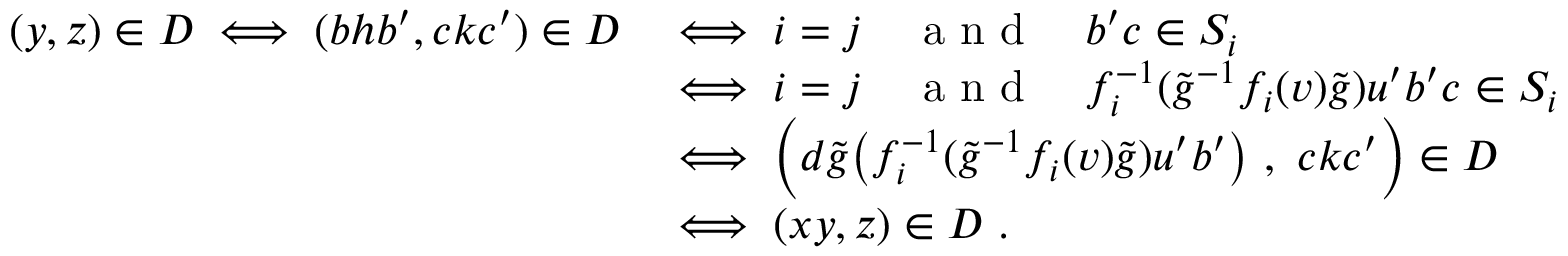<formula> <loc_0><loc_0><loc_500><loc_500>\begin{array} { r l } { ( y , z ) \in D \iff ( b h b ^ { \prime } , c k c ^ { \prime } ) \in D } & { \iff i = j \quad a n d \quad b ^ { \prime } c \in S _ { i } } \\ & { \iff i = j \quad a n d \quad f _ { i } ^ { - 1 } ( \widetilde { g } ^ { - 1 } f _ { i } ( v ) \widetilde { g } ) u ^ { \prime } b ^ { \prime } c \in S _ { i } } \\ & { \iff \left ( d \widetilde { g } \left ( f _ { i } ^ { - 1 } ( \widetilde { g } ^ { - 1 } f _ { i } ( v ) \widetilde { g } ) u ^ { \prime } b ^ { \prime } \right ) \ , \ c k c ^ { \prime } \right ) \in D } \\ & { \iff ( x y , z ) \in D \ . } \end{array}</formula> 